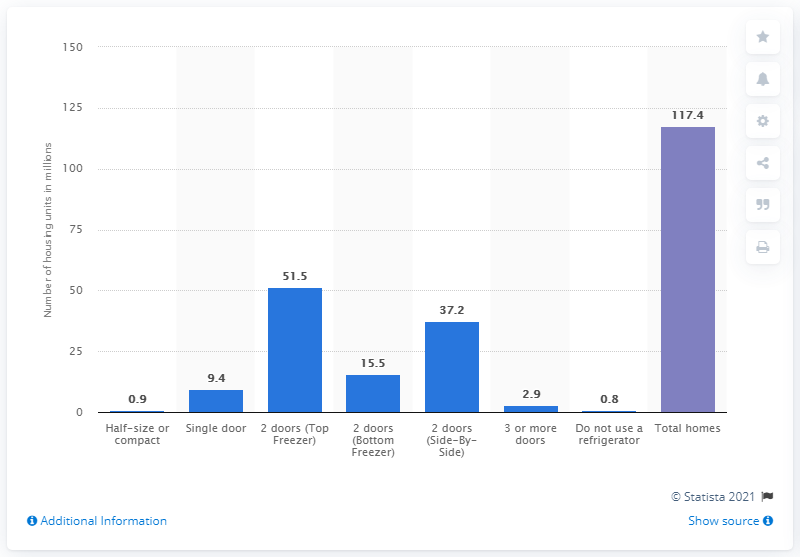Mention a couple of crucial points in this snapshot. In 2015, 51.5 housing units used a top freezer with two doors. 